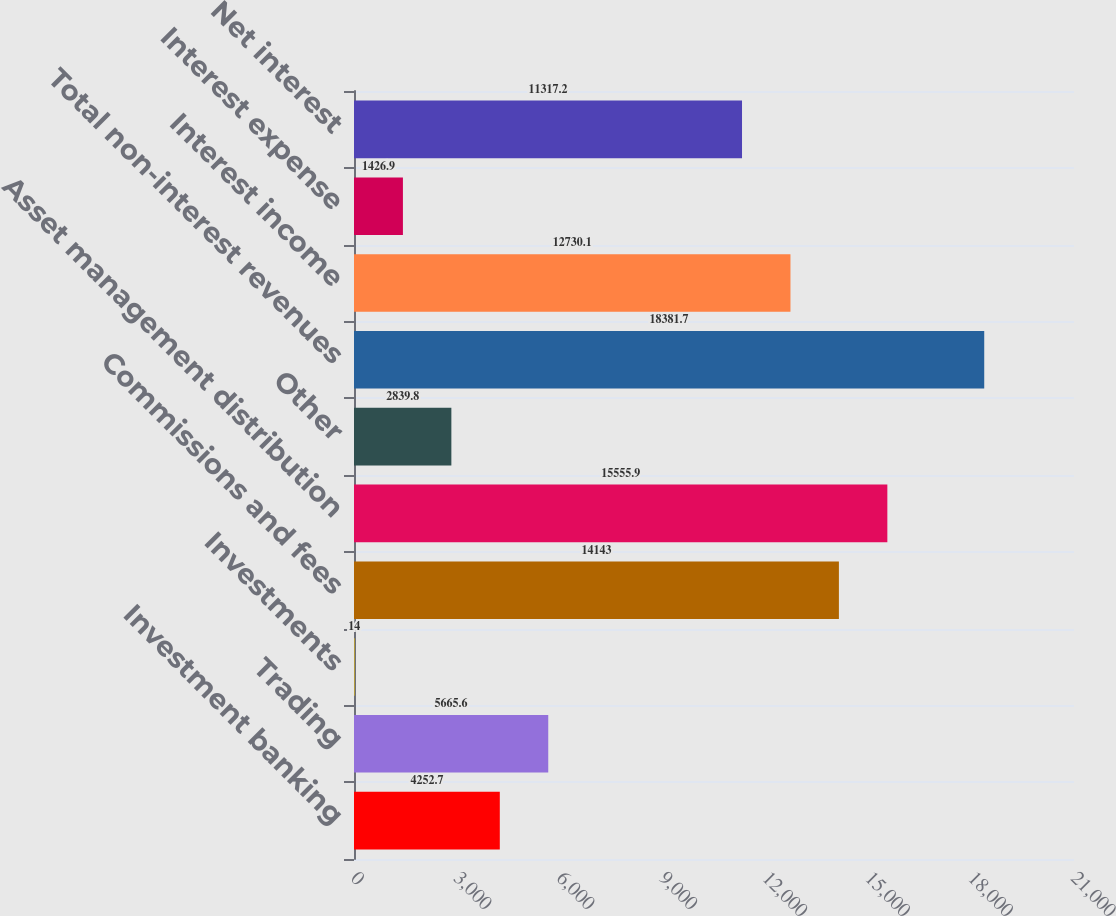<chart> <loc_0><loc_0><loc_500><loc_500><bar_chart><fcel>Investment banking<fcel>Trading<fcel>Investments<fcel>Commissions and fees<fcel>Asset management distribution<fcel>Other<fcel>Total non-interest revenues<fcel>Interest income<fcel>Interest expense<fcel>Net interest<nl><fcel>4252.7<fcel>5665.6<fcel>14<fcel>14143<fcel>15555.9<fcel>2839.8<fcel>18381.7<fcel>12730.1<fcel>1426.9<fcel>11317.2<nl></chart> 